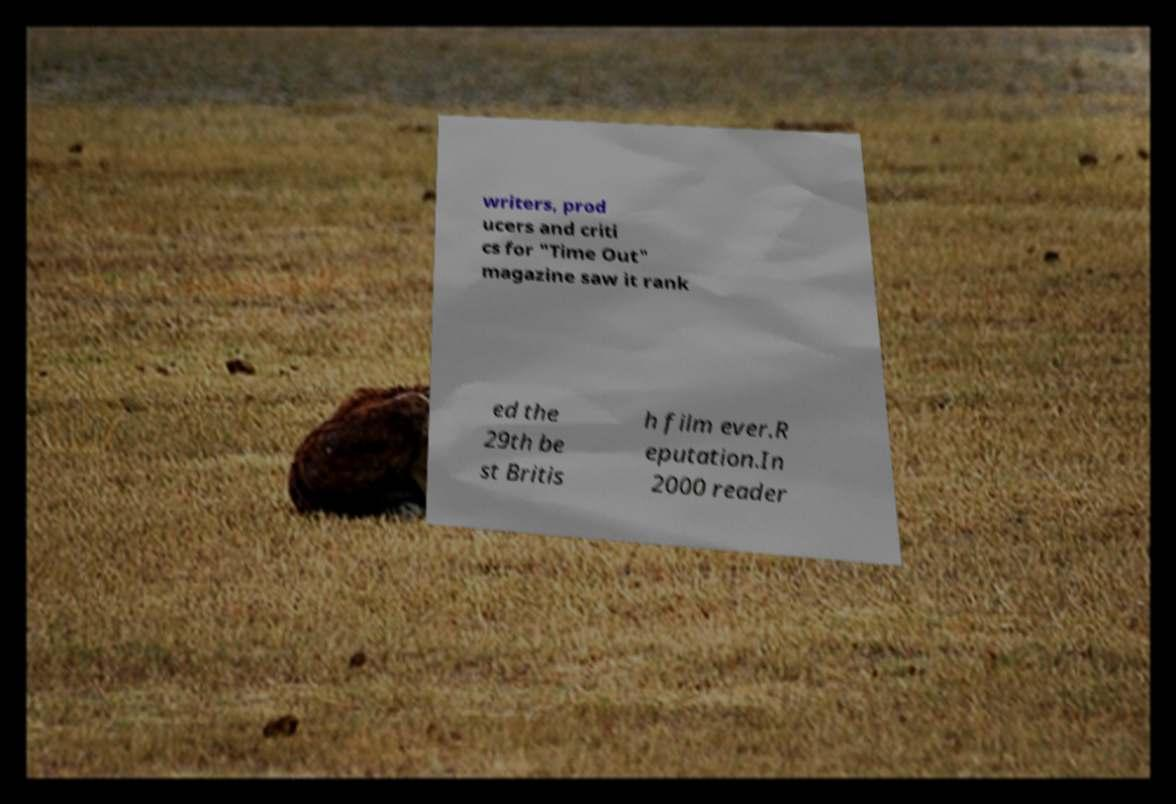Can you accurately transcribe the text from the provided image for me? writers, prod ucers and criti cs for "Time Out" magazine saw it rank ed the 29th be st Britis h film ever.R eputation.In 2000 reader 